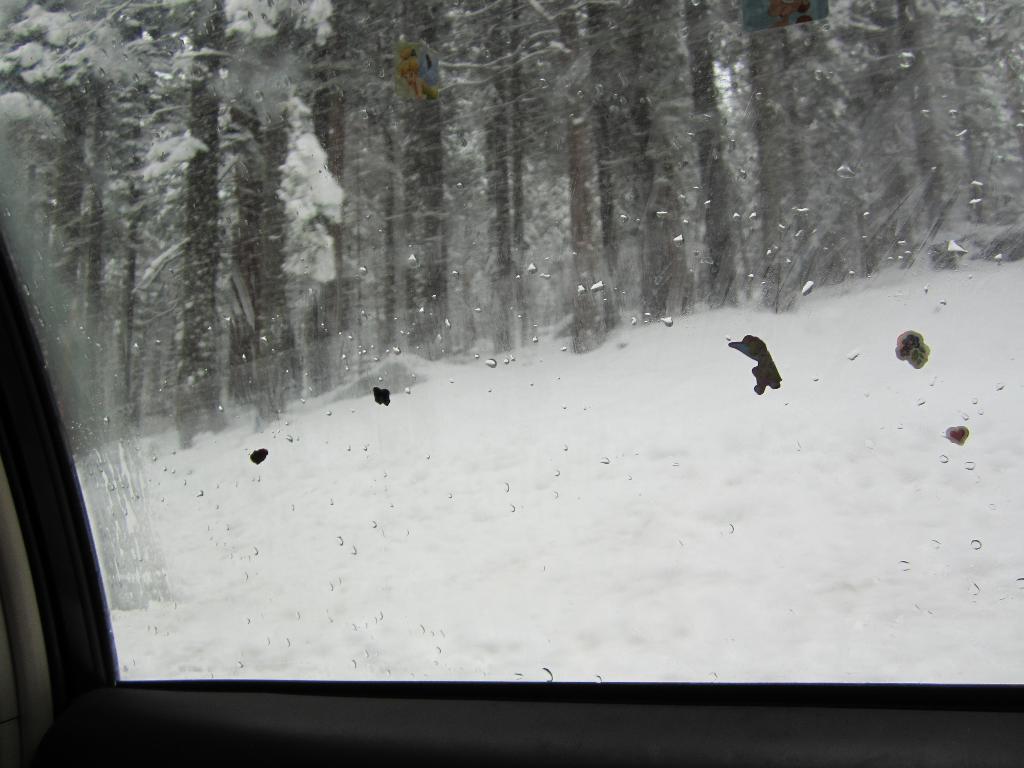Describe this image in one or two sentences. This is glass. From the glass we can see snow and trees. 